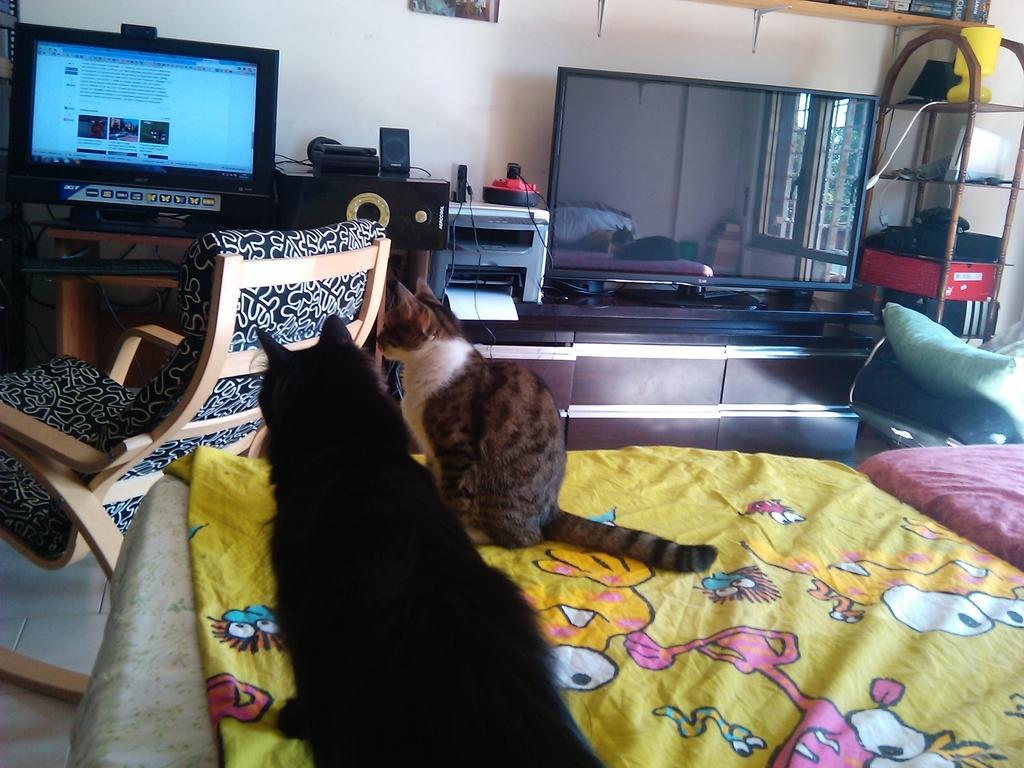In one or two sentences, can you explain what this image depicts? In this image there is a bed towards the bottom of the image, there are blankets, there is a pillow, there are two cats, there is a chair, there are tables, there is a monitor towards the left of the image, there is a keyboard, there is a television, there is a printer, there are papers, there is a shelf towards the right of the image, there are objects in the shelves, at the background of the image there is a wall, there is a photo frame towards the top of the image. 